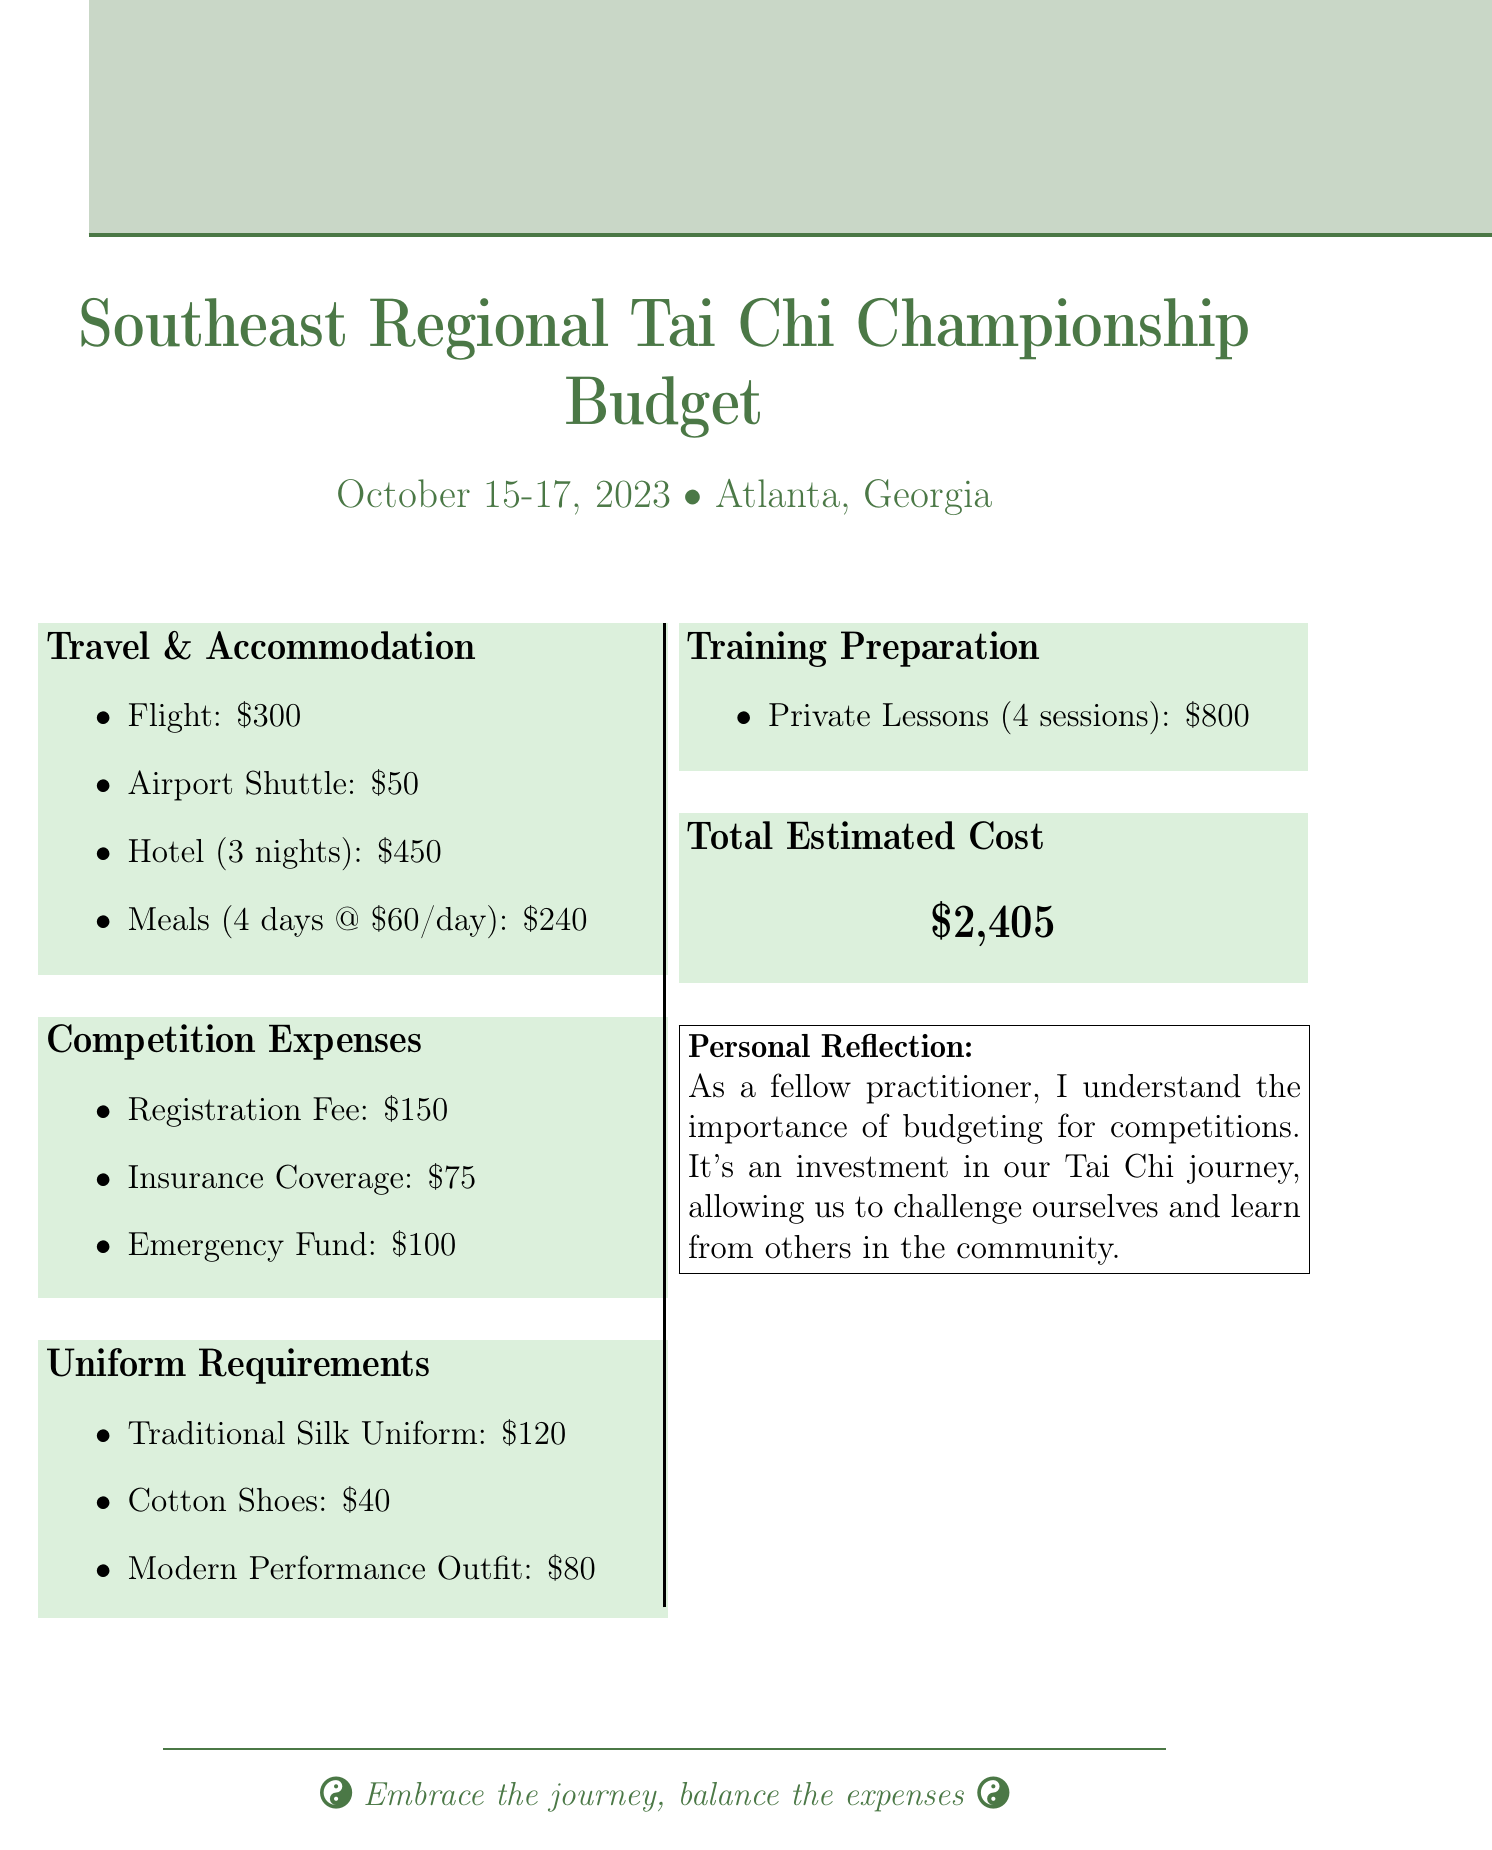What is the registration fee for the competition? The registration fee is listed under competition expenses in the document.
Answer: $150 How much is allocated for meals during the competition? The total meal expense is derived from the daily meal cost and the number of days specified in the travel section.
Answer: $240 What is the total estimated cost for participating? The total estimated cost is summarized at the end of the budget document.
Answer: $2,405 What is the cost of the traditional silk uniform? The cost of the traditional silk uniform is found under the uniform requirements section.
Answer: $120 How many nights is the hotel accommodation budgeted for? The number of hotel nights is specified in the travel and accommodation section.
Answer: 3 nights What amount is set aside for the emergency fund? The emergency fund amount is listed under competition expenses.
Answer: $100 What are the travel expenses total? The travel expenses total is the sum of all the items listed in the travel and accommodation section.
Answer: $1,040 How many private training lessons are included in the preparation budget? The number of private lessons is stated in the training preparation section.
Answer: 4 sessions What type of shoes are included in the uniform requirements? The document specifically lists the type of shoes required under the uniform section.
Answer: Cotton Shoes 